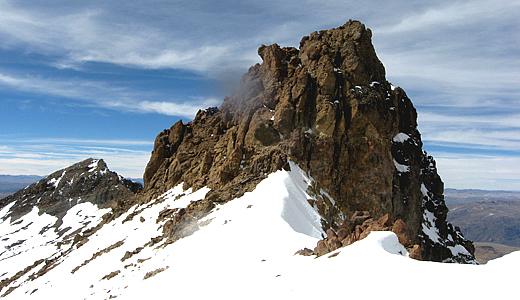What kind of flora and fauna are native to the region around Nevado Mismi? The region surrounding Nevado Mismi, due to its high-altitude environment, hosts a range of specialized flora and fauna adapted to its harsh conditions. Common flora include Ichhu grass, which is adapted to survive in thin soil and harsh weather, and Polylepis, a genus of small trees and shrubs that thrive in high-altitude conditions. As for fauna, the Andean condor can be seen soaring the skies, its large wings perfectly adapted for high-altitude flight. Other wildlife includes the vicuña, a wild relative of the llama, which grazes on the sparse vegetation found in these regions. Smaller mammals like the Andean fox and various species of rodents are also found here, alongside specialized bird species such as the Andean hillstar hummingbird. What challenges might wildlife face living in such a high-altitude environment? Wildlife in high-altitude environments like Nevado Mismi faces several significant challenges. The most critical is the low oxygen level due to the thin atmosphere, which can be challenging for respiration. The cold temperatures also pose a risk of hypothermia, necessitating adaptations like thicker fur or specialized behaviors to stay warm. Limited vegetation means food can be scarce, challenging herbivores and, in turn, the predators that rely on them. Additionally, the harsh terrain and weather conditions can make movement and foraging difficult. Animals in this region often have specialized physical and behavioral adaptations to cope with these conditions, such as the small body size and high metabolic rates of many mammals, which help conserve heat, and the altitudinal migration of birds to lower elevations during colder months. 